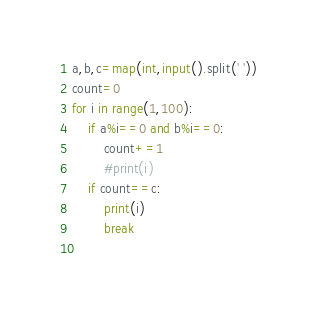Convert code to text. <code><loc_0><loc_0><loc_500><loc_500><_Python_>a,b,c=map(int,input().split(' '))
count=0
for i in range(1,100):
    if a%i==0 and b%i==0:
        count+=1
        #print(i)
    if count==c:
        print(i)
        break
    
</code> 